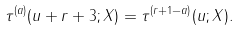Convert formula to latex. <formula><loc_0><loc_0><loc_500><loc_500>\tau ^ { ( a ) } ( u + r + 3 ; X ) = \tau ^ { ( r + 1 - a ) } ( u ; X ) .</formula> 